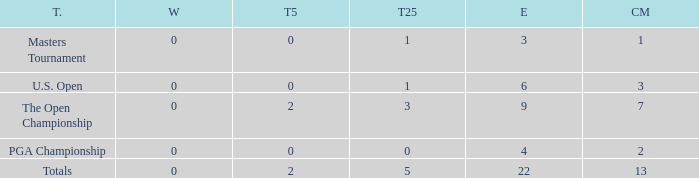What is the average number of cuts made for events with 0 top-5s? None. 